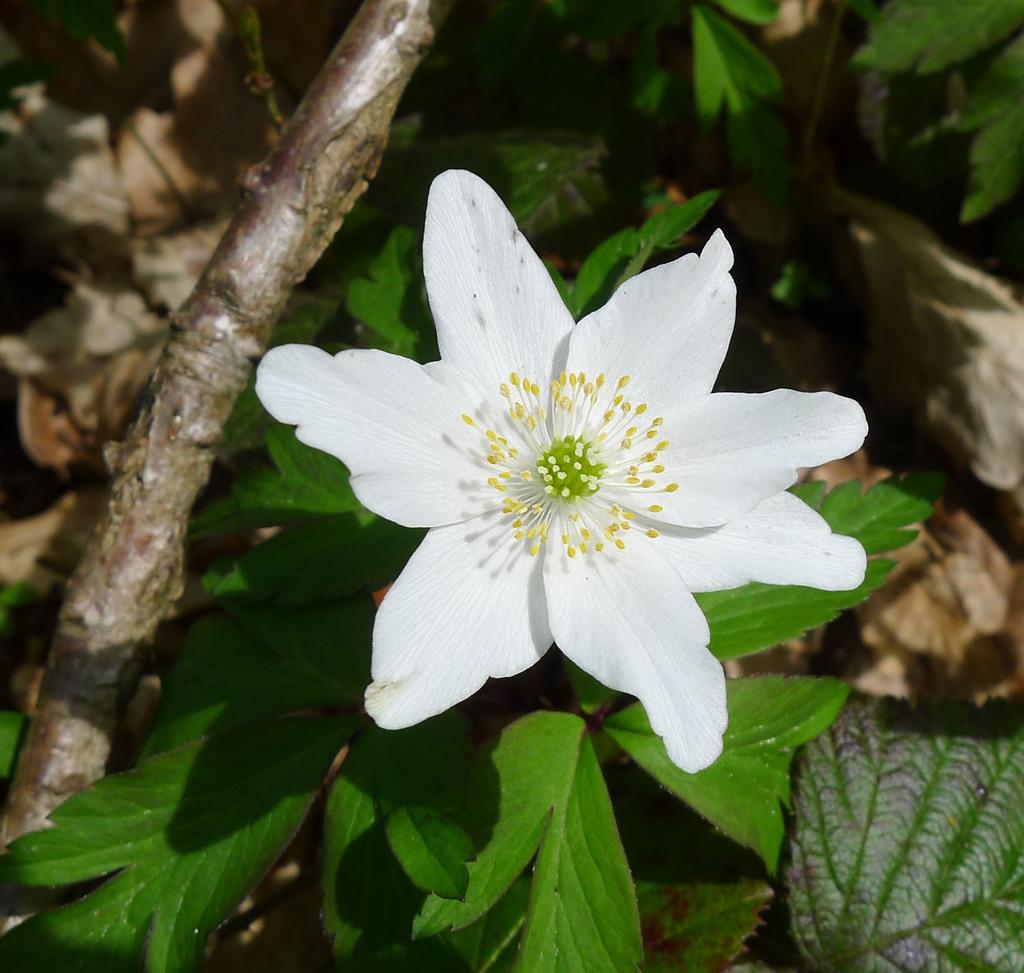What type of flower is in the image? There is a white flower in the image. What can be seen in the background of the image? There are green leaves and a stem in the background of the image. What type of wire is holding up the donkey in the image? There is no wire or donkey present in the image; it only features a white flower and green leaves in the background. 